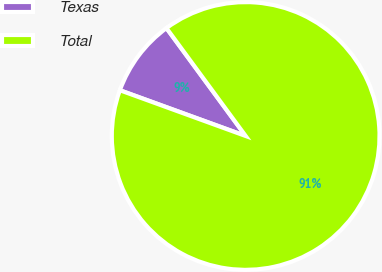<chart> <loc_0><loc_0><loc_500><loc_500><pie_chart><fcel>Texas<fcel>Total<nl><fcel>9.37%<fcel>90.63%<nl></chart> 